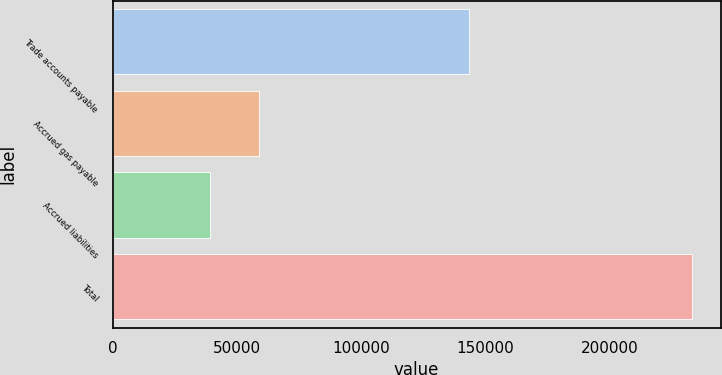Convert chart to OTSL. <chart><loc_0><loc_0><loc_500><loc_500><bar_chart><fcel>Trade accounts payable<fcel>Accrued gas payable<fcel>Accrued liabilities<fcel>Total<nl><fcel>143422<fcel>58742.5<fcel>39375<fcel>233050<nl></chart> 